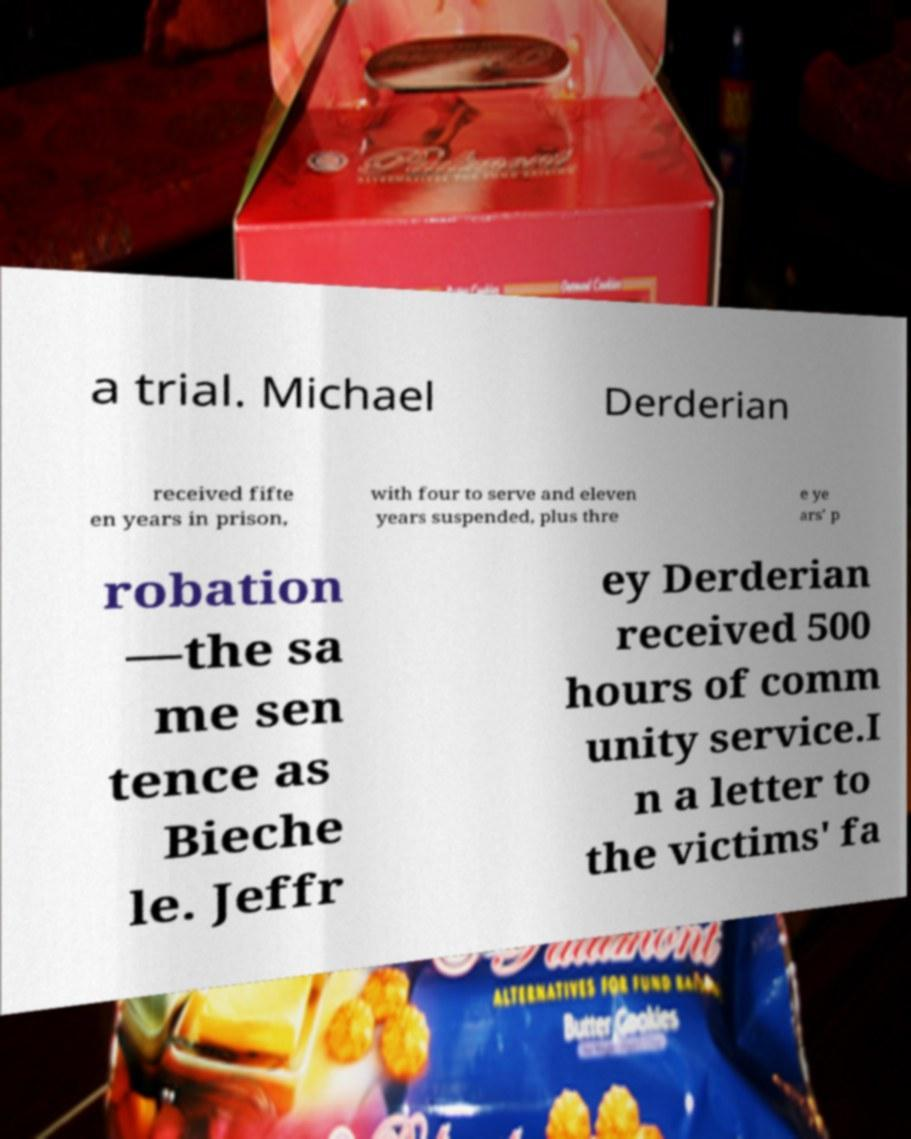There's text embedded in this image that I need extracted. Can you transcribe it verbatim? a trial. Michael Derderian received fifte en years in prison, with four to serve and eleven years suspended, plus thre e ye ars' p robation —the sa me sen tence as Bieche le. Jeffr ey Derderian received 500 hours of comm unity service.I n a letter to the victims' fa 